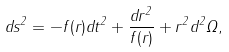<formula> <loc_0><loc_0><loc_500><loc_500>d s ^ { 2 } = - f ( r ) d t ^ { 2 } + \frac { d r ^ { 2 } } { f ( r ) } + r ^ { 2 } d ^ { 2 } \Omega ,</formula> 